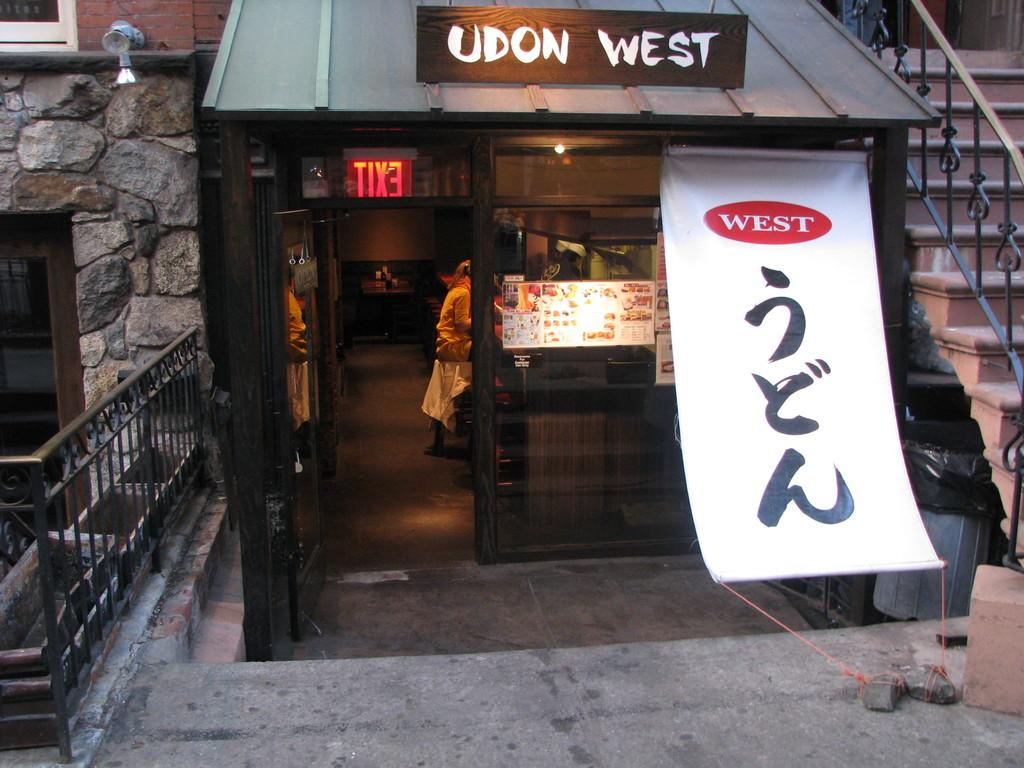<image>
Relay a brief, clear account of the picture shown. The entrance to a store has a sign saying Udon West. 